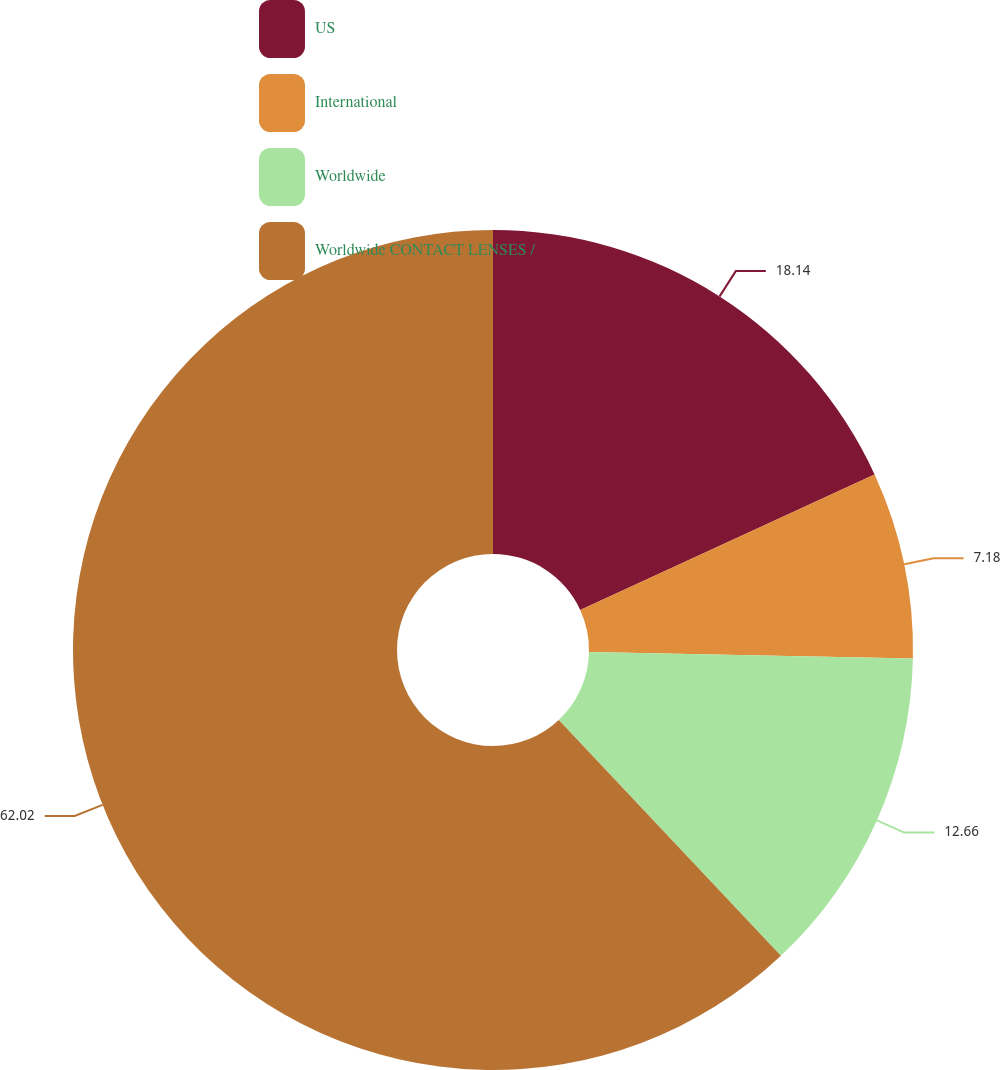Convert chart to OTSL. <chart><loc_0><loc_0><loc_500><loc_500><pie_chart><fcel>US<fcel>International<fcel>Worldwide<fcel>Worldwide CONTACT LENSES /<nl><fcel>18.14%<fcel>7.18%<fcel>12.66%<fcel>62.02%<nl></chart> 